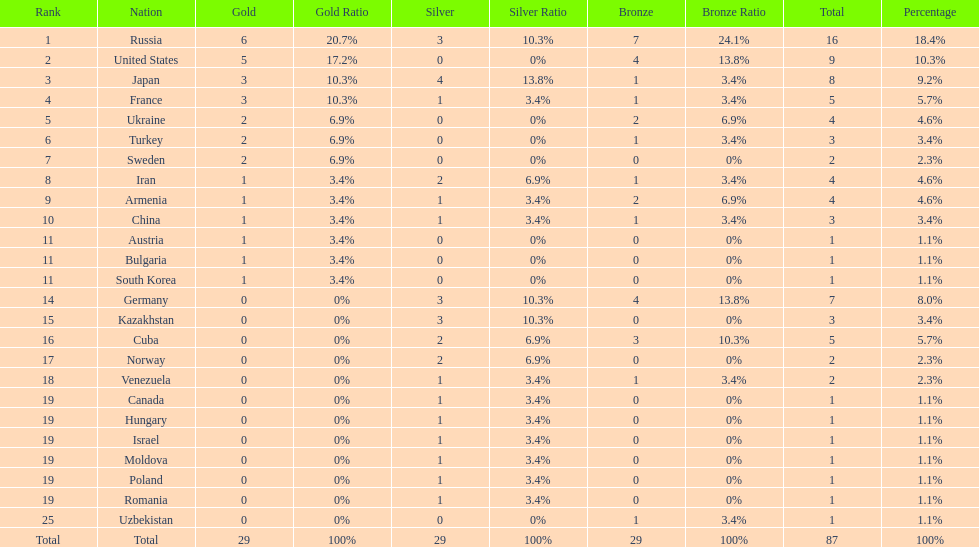Which country won only one medal, a bronze medal? Uzbekistan. 